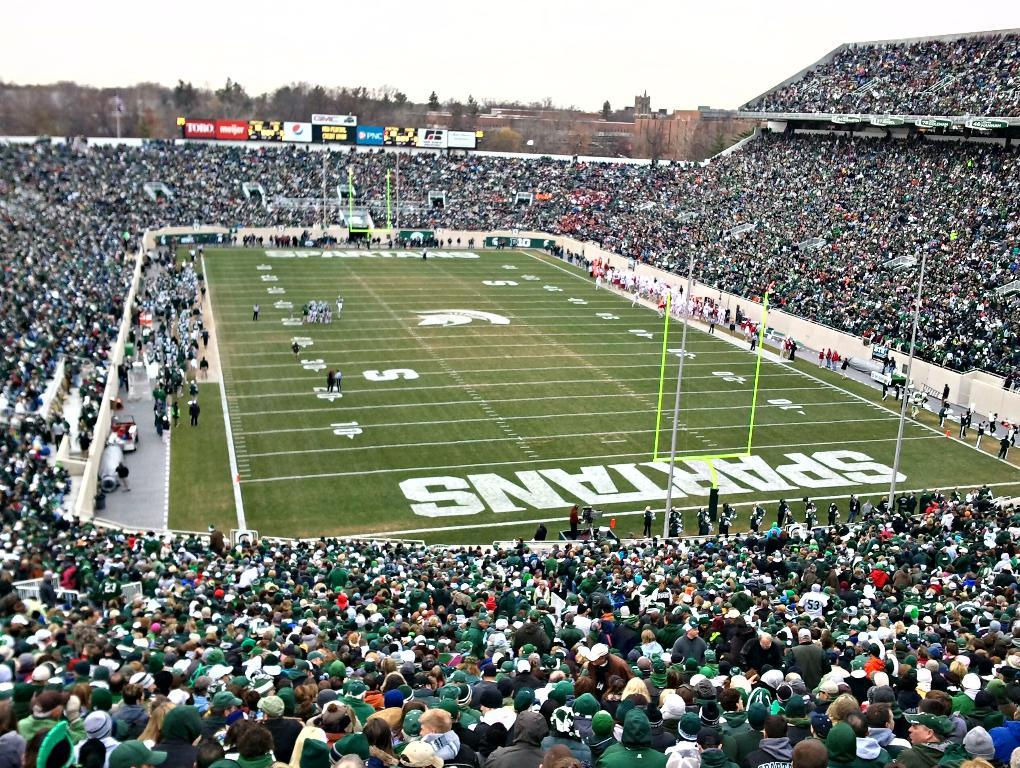<image>
Offer a succinct explanation of the picture presented. Overview of a football stadium that is home of the Spartans. 